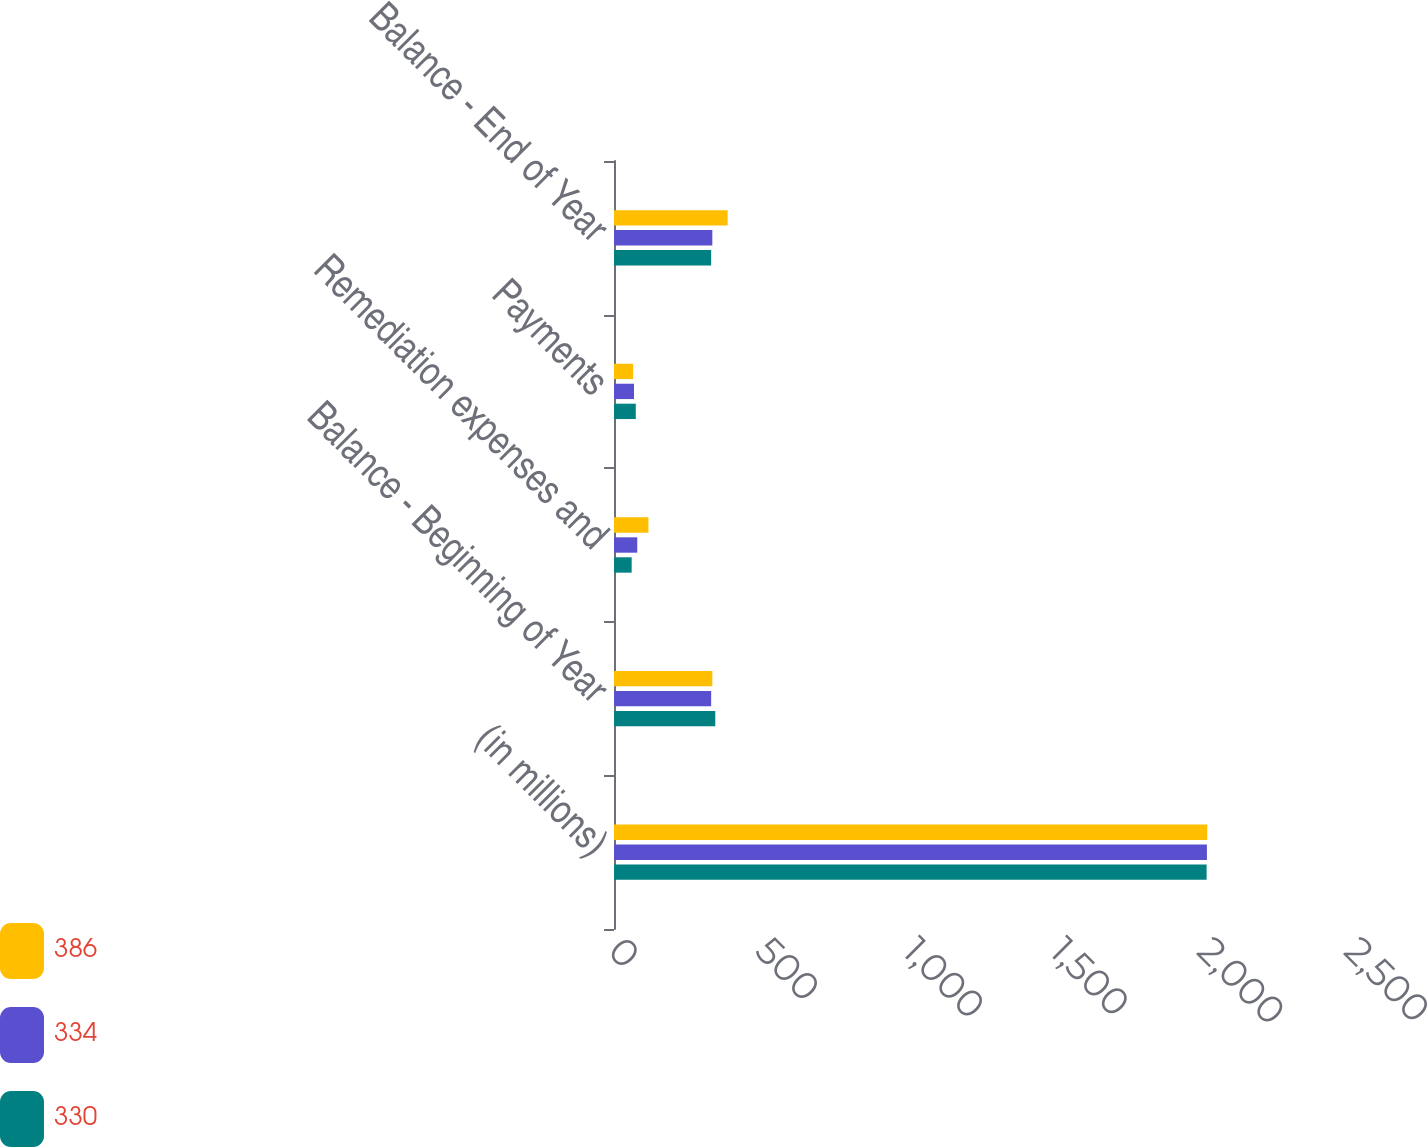<chart> <loc_0><loc_0><loc_500><loc_500><stacked_bar_chart><ecel><fcel>(in millions)<fcel>Balance - Beginning of Year<fcel>Remediation expenses and<fcel>Payments<fcel>Balance - End of Year<nl><fcel>386<fcel>2015<fcel>334<fcel>117<fcel>65<fcel>386<nl><fcel>334<fcel>2014<fcel>330<fcel>79<fcel>68<fcel>334<nl><fcel>330<fcel>2013<fcel>344<fcel>60<fcel>74<fcel>330<nl></chart> 